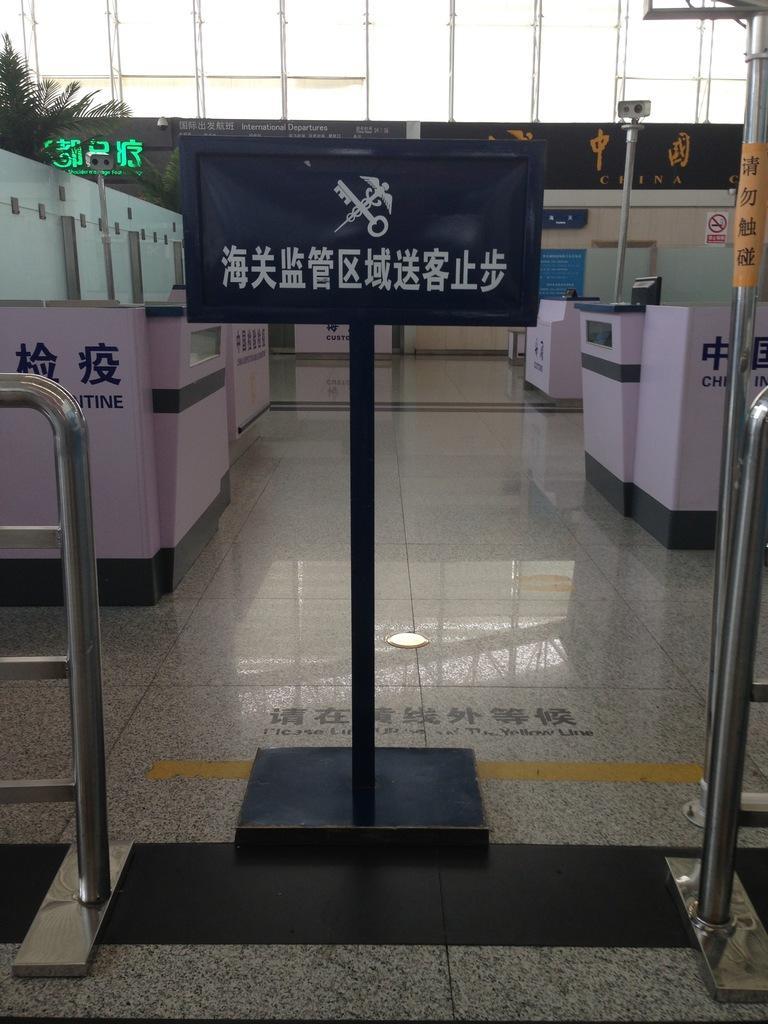Please provide a concise description of this image. In this image we can see a board with something written on a stand. On the sides there are railings. Also there are blocks with something written. On the left side there are trees. In the back there is a building with something written on that. 